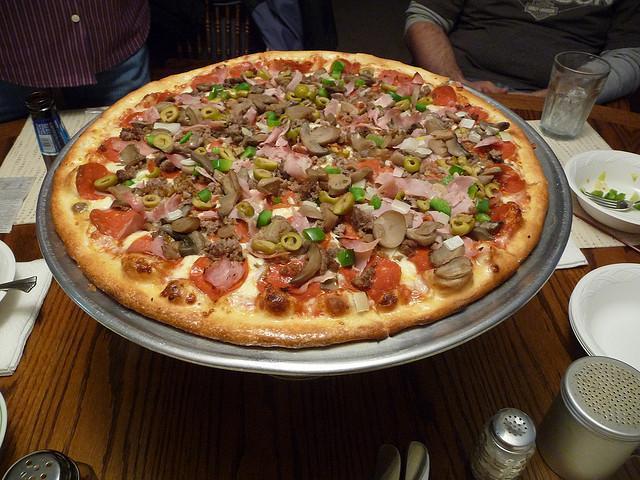Does the caption "The pizza is on the dining table." correctly depict the image?
Answer yes or no. Yes. 